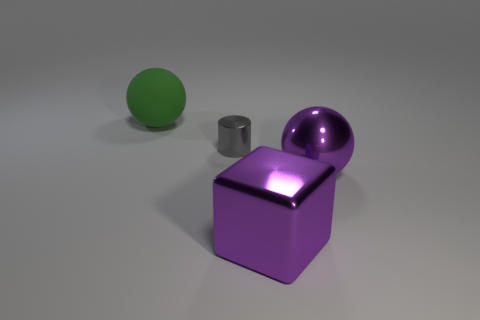Is there any other thing that is the same shape as the gray thing?
Give a very brief answer. No. There is a large object that is in front of the big metallic object behind the purple block; what is its material?
Provide a succinct answer. Metal. Is there any other thing that has the same color as the rubber sphere?
Your answer should be compact. No. There is a gray metallic thing; does it have the same shape as the large thing that is behind the small thing?
Keep it short and to the point. No. What is the color of the large thing that is behind the large sphere that is in front of the big sphere that is on the left side of the small metal thing?
Keep it short and to the point. Green. Is there any other thing that has the same material as the green object?
Your response must be concise. No. There is a large purple metal object that is to the right of the large block; is it the same shape as the matte thing?
Offer a terse response. Yes. What is the material of the gray cylinder?
Provide a short and direct response. Metal. What is the shape of the tiny gray thing on the left side of the purple object that is in front of the big sphere that is in front of the metal cylinder?
Offer a very short reply. Cylinder. How many other objects are the same shape as the tiny gray metallic thing?
Ensure brevity in your answer.  0. 